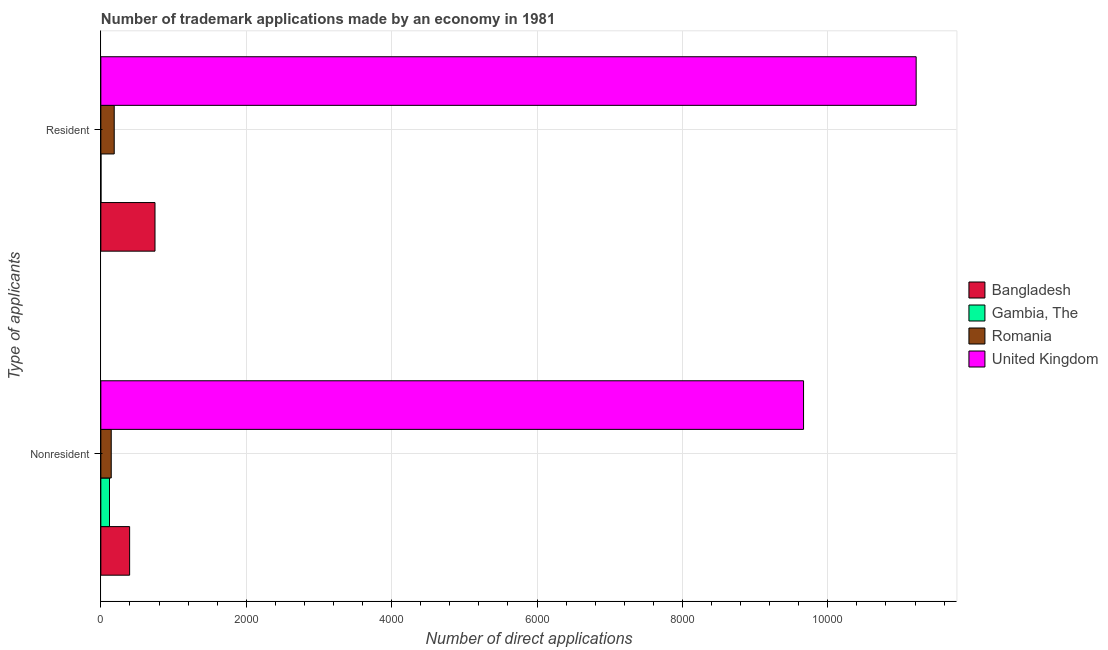How many different coloured bars are there?
Keep it short and to the point. 4. How many groups of bars are there?
Offer a terse response. 2. Are the number of bars per tick equal to the number of legend labels?
Your answer should be compact. Yes. What is the label of the 1st group of bars from the top?
Give a very brief answer. Resident. What is the number of trademark applications made by residents in Romania?
Keep it short and to the point. 184. Across all countries, what is the maximum number of trademark applications made by non residents?
Keep it short and to the point. 9666. Across all countries, what is the minimum number of trademark applications made by residents?
Your answer should be very brief. 2. In which country was the number of trademark applications made by residents minimum?
Make the answer very short. Gambia, The. What is the total number of trademark applications made by non residents in the graph?
Your response must be concise. 1.03e+04. What is the difference between the number of trademark applications made by non residents in Romania and that in Bangladesh?
Provide a short and direct response. -253. What is the difference between the number of trademark applications made by residents in Gambia, The and the number of trademark applications made by non residents in Bangladesh?
Provide a short and direct response. -394. What is the average number of trademark applications made by residents per country?
Make the answer very short. 3036.5. What is the difference between the number of trademark applications made by non residents and number of trademark applications made by residents in Romania?
Provide a succinct answer. -41. What is the ratio of the number of trademark applications made by non residents in Gambia, The to that in United Kingdom?
Ensure brevity in your answer.  0.01. In how many countries, is the number of trademark applications made by non residents greater than the average number of trademark applications made by non residents taken over all countries?
Provide a short and direct response. 1. What does the 4th bar from the top in Nonresident represents?
Your answer should be compact. Bangladesh. What does the 2nd bar from the bottom in Nonresident represents?
Provide a short and direct response. Gambia, The. Are all the bars in the graph horizontal?
Your response must be concise. Yes. How many countries are there in the graph?
Give a very brief answer. 4. Does the graph contain any zero values?
Provide a succinct answer. No. Where does the legend appear in the graph?
Provide a short and direct response. Center right. How many legend labels are there?
Provide a short and direct response. 4. How are the legend labels stacked?
Provide a short and direct response. Vertical. What is the title of the graph?
Your answer should be compact. Number of trademark applications made by an economy in 1981. What is the label or title of the X-axis?
Make the answer very short. Number of direct applications. What is the label or title of the Y-axis?
Provide a succinct answer. Type of applicants. What is the Number of direct applications of Bangladesh in Nonresident?
Give a very brief answer. 396. What is the Number of direct applications in Gambia, The in Nonresident?
Your response must be concise. 119. What is the Number of direct applications of Romania in Nonresident?
Your answer should be very brief. 143. What is the Number of direct applications of United Kingdom in Nonresident?
Your response must be concise. 9666. What is the Number of direct applications in Bangladesh in Resident?
Your answer should be compact. 745. What is the Number of direct applications in Gambia, The in Resident?
Provide a succinct answer. 2. What is the Number of direct applications in Romania in Resident?
Offer a terse response. 184. What is the Number of direct applications of United Kingdom in Resident?
Offer a terse response. 1.12e+04. Across all Type of applicants, what is the maximum Number of direct applications in Bangladesh?
Your answer should be compact. 745. Across all Type of applicants, what is the maximum Number of direct applications of Gambia, The?
Offer a very short reply. 119. Across all Type of applicants, what is the maximum Number of direct applications of Romania?
Provide a succinct answer. 184. Across all Type of applicants, what is the maximum Number of direct applications of United Kingdom?
Give a very brief answer. 1.12e+04. Across all Type of applicants, what is the minimum Number of direct applications in Bangladesh?
Your answer should be compact. 396. Across all Type of applicants, what is the minimum Number of direct applications in Romania?
Your response must be concise. 143. Across all Type of applicants, what is the minimum Number of direct applications in United Kingdom?
Offer a very short reply. 9666. What is the total Number of direct applications in Bangladesh in the graph?
Make the answer very short. 1141. What is the total Number of direct applications in Gambia, The in the graph?
Your answer should be very brief. 121. What is the total Number of direct applications of Romania in the graph?
Make the answer very short. 327. What is the total Number of direct applications in United Kingdom in the graph?
Make the answer very short. 2.09e+04. What is the difference between the Number of direct applications of Bangladesh in Nonresident and that in Resident?
Offer a terse response. -349. What is the difference between the Number of direct applications in Gambia, The in Nonresident and that in Resident?
Give a very brief answer. 117. What is the difference between the Number of direct applications in Romania in Nonresident and that in Resident?
Your answer should be very brief. -41. What is the difference between the Number of direct applications in United Kingdom in Nonresident and that in Resident?
Make the answer very short. -1549. What is the difference between the Number of direct applications of Bangladesh in Nonresident and the Number of direct applications of Gambia, The in Resident?
Your answer should be compact. 394. What is the difference between the Number of direct applications in Bangladesh in Nonresident and the Number of direct applications in Romania in Resident?
Provide a short and direct response. 212. What is the difference between the Number of direct applications of Bangladesh in Nonresident and the Number of direct applications of United Kingdom in Resident?
Your response must be concise. -1.08e+04. What is the difference between the Number of direct applications in Gambia, The in Nonresident and the Number of direct applications in Romania in Resident?
Keep it short and to the point. -65. What is the difference between the Number of direct applications of Gambia, The in Nonresident and the Number of direct applications of United Kingdom in Resident?
Give a very brief answer. -1.11e+04. What is the difference between the Number of direct applications of Romania in Nonresident and the Number of direct applications of United Kingdom in Resident?
Offer a very short reply. -1.11e+04. What is the average Number of direct applications of Bangladesh per Type of applicants?
Your answer should be very brief. 570.5. What is the average Number of direct applications in Gambia, The per Type of applicants?
Give a very brief answer. 60.5. What is the average Number of direct applications in Romania per Type of applicants?
Make the answer very short. 163.5. What is the average Number of direct applications of United Kingdom per Type of applicants?
Offer a very short reply. 1.04e+04. What is the difference between the Number of direct applications of Bangladesh and Number of direct applications of Gambia, The in Nonresident?
Provide a short and direct response. 277. What is the difference between the Number of direct applications of Bangladesh and Number of direct applications of Romania in Nonresident?
Offer a very short reply. 253. What is the difference between the Number of direct applications of Bangladesh and Number of direct applications of United Kingdom in Nonresident?
Make the answer very short. -9270. What is the difference between the Number of direct applications in Gambia, The and Number of direct applications in United Kingdom in Nonresident?
Ensure brevity in your answer.  -9547. What is the difference between the Number of direct applications of Romania and Number of direct applications of United Kingdom in Nonresident?
Make the answer very short. -9523. What is the difference between the Number of direct applications of Bangladesh and Number of direct applications of Gambia, The in Resident?
Your answer should be very brief. 743. What is the difference between the Number of direct applications in Bangladesh and Number of direct applications in Romania in Resident?
Offer a very short reply. 561. What is the difference between the Number of direct applications in Bangladesh and Number of direct applications in United Kingdom in Resident?
Give a very brief answer. -1.05e+04. What is the difference between the Number of direct applications of Gambia, The and Number of direct applications of Romania in Resident?
Offer a terse response. -182. What is the difference between the Number of direct applications in Gambia, The and Number of direct applications in United Kingdom in Resident?
Your answer should be very brief. -1.12e+04. What is the difference between the Number of direct applications in Romania and Number of direct applications in United Kingdom in Resident?
Your response must be concise. -1.10e+04. What is the ratio of the Number of direct applications in Bangladesh in Nonresident to that in Resident?
Provide a succinct answer. 0.53. What is the ratio of the Number of direct applications of Gambia, The in Nonresident to that in Resident?
Offer a terse response. 59.5. What is the ratio of the Number of direct applications of Romania in Nonresident to that in Resident?
Offer a very short reply. 0.78. What is the ratio of the Number of direct applications in United Kingdom in Nonresident to that in Resident?
Make the answer very short. 0.86. What is the difference between the highest and the second highest Number of direct applications in Bangladesh?
Your response must be concise. 349. What is the difference between the highest and the second highest Number of direct applications of Gambia, The?
Provide a short and direct response. 117. What is the difference between the highest and the second highest Number of direct applications of Romania?
Your response must be concise. 41. What is the difference between the highest and the second highest Number of direct applications in United Kingdom?
Keep it short and to the point. 1549. What is the difference between the highest and the lowest Number of direct applications of Bangladesh?
Make the answer very short. 349. What is the difference between the highest and the lowest Number of direct applications of Gambia, The?
Your answer should be compact. 117. What is the difference between the highest and the lowest Number of direct applications of Romania?
Ensure brevity in your answer.  41. What is the difference between the highest and the lowest Number of direct applications of United Kingdom?
Make the answer very short. 1549. 